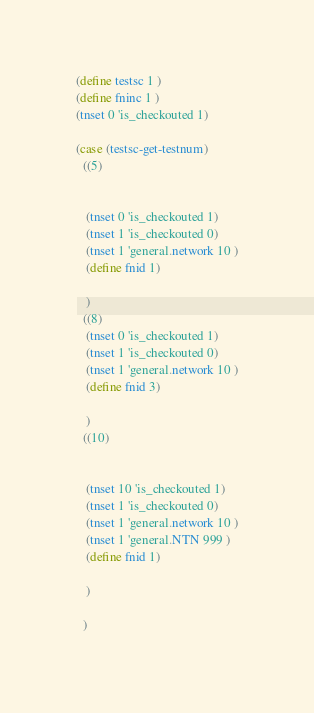Convert code to text. <code><loc_0><loc_0><loc_500><loc_500><_Scheme_>

(define testsc 1 )
(define fninc 1 )
(tnset 0 'is_checkouted 1)

(case (testsc-get-testnum)
  ((5)


   (tnset 0 'is_checkouted 1)
   (tnset 1 'is_checkouted 0)
   (tnset 1 'general.network 10 )
   (define fnid 1)

   )
  ((8)
   (tnset 0 'is_checkouted 1)
   (tnset 1 'is_checkouted 0)
   (tnset 1 'general.network 10 )
   (define fnid 3)

   )
  ((10)


   (tnset 10 'is_checkouted 1)
   (tnset 1 'is_checkouted 0)
   (tnset 1 'general.network 10 )
   (tnset 1 'general.NTN 999 )
   (define fnid 1)

   )

  )
</code> 